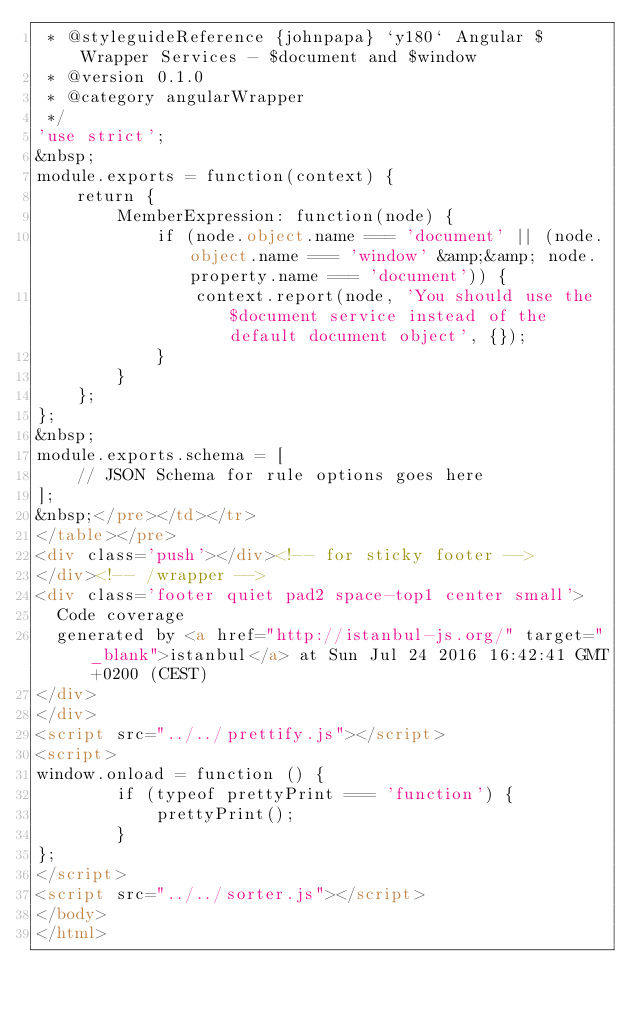Convert code to text. <code><loc_0><loc_0><loc_500><loc_500><_HTML_> * @styleguideReference {johnpapa} `y180` Angular $ Wrapper Services - $document and $window
 * @version 0.1.0
 * @category angularWrapper
 */
'use strict';
&nbsp;
module.exports = function(context) {
    return {
        MemberExpression: function(node) {
            if (node.object.name === 'document' || (node.object.name === 'window' &amp;&amp; node.property.name === 'document')) {
                context.report(node, 'You should use the $document service instead of the default document object', {});
            }
        }
    };
};
&nbsp;
module.exports.schema = [
    // JSON Schema for rule options goes here
];
&nbsp;</pre></td></tr>
</table></pre>
<div class='push'></div><!-- for sticky footer -->
</div><!-- /wrapper -->
<div class='footer quiet pad2 space-top1 center small'>
  Code coverage
  generated by <a href="http://istanbul-js.org/" target="_blank">istanbul</a> at Sun Jul 24 2016 16:42:41 GMT+0200 (CEST)
</div>
</div>
<script src="../../prettify.js"></script>
<script>
window.onload = function () {
        if (typeof prettyPrint === 'function') {
            prettyPrint();
        }
};
</script>
<script src="../../sorter.js"></script>
</body>
</html>
</code> 